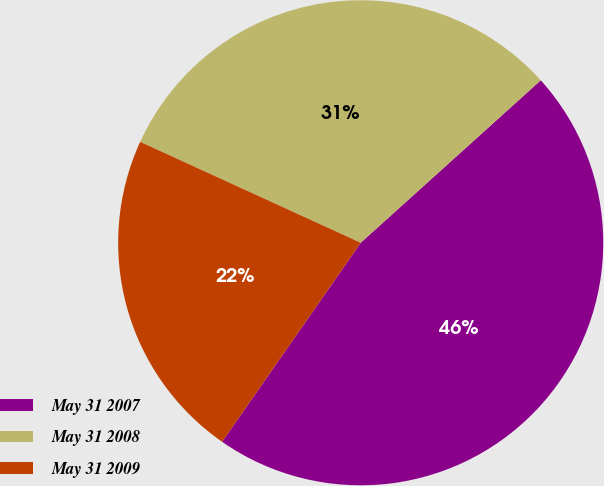Convert chart to OTSL. <chart><loc_0><loc_0><loc_500><loc_500><pie_chart><fcel>May 31 2007<fcel>May 31 2008<fcel>May 31 2009<nl><fcel>46.37%<fcel>31.49%<fcel>22.15%<nl></chart> 